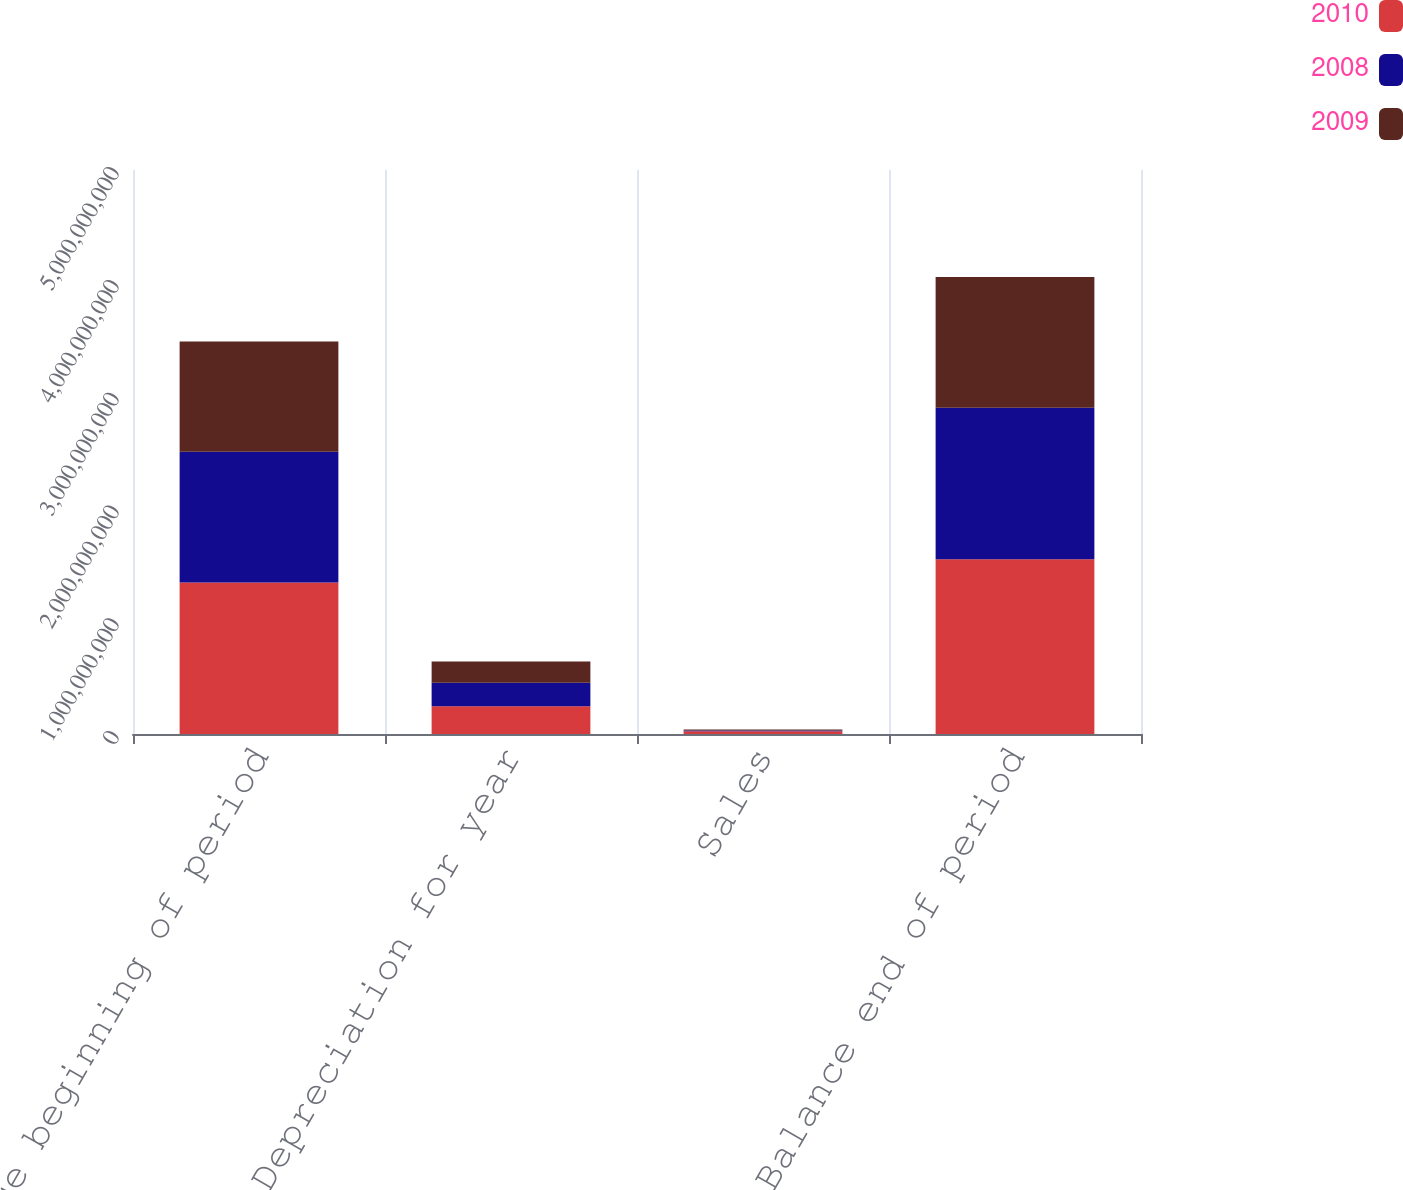<chart> <loc_0><loc_0><loc_500><loc_500><stacked_bar_chart><ecel><fcel>Balance beginning of period<fcel>Depreciation for year<fcel>Sales<fcel>Balance end of period<nl><fcel>2010<fcel>1.34315e+09<fcel>2.44904e+08<fcel>2.36109e+07<fcel>1.54938e+09<nl><fcel>2008<fcel>1.15966e+09<fcel>2.1e+08<fcel>8.46425e+06<fcel>1.34315e+09<nl><fcel>2009<fcel>9.77444e+08<fcel>1.87779e+08<fcel>7.59555e+06<fcel>1.15966e+09<nl></chart> 